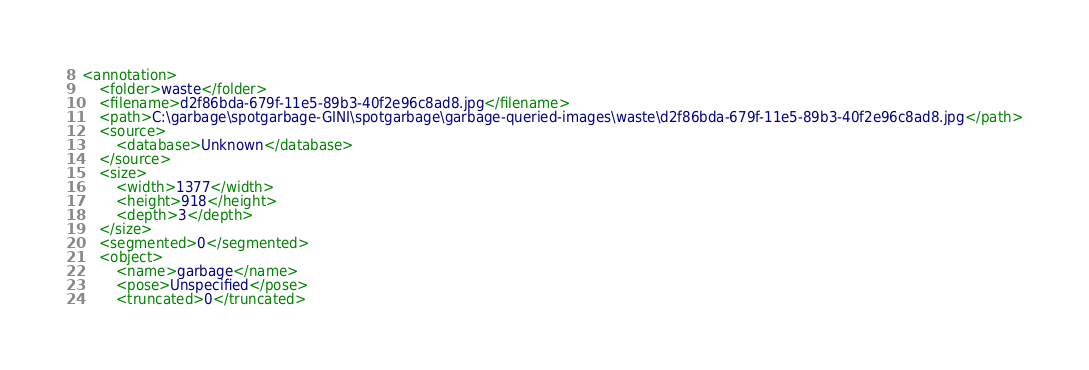<code> <loc_0><loc_0><loc_500><loc_500><_XML_><annotation>
	<folder>waste</folder>
	<filename>d2f86bda-679f-11e5-89b3-40f2e96c8ad8.jpg</filename>
	<path>C:\garbage\spotgarbage-GINI\spotgarbage\garbage-queried-images\waste\d2f86bda-679f-11e5-89b3-40f2e96c8ad8.jpg</path>
	<source>
		<database>Unknown</database>
	</source>
	<size>
		<width>1377</width>
		<height>918</height>
		<depth>3</depth>
	</size>
	<segmented>0</segmented>
	<object>
		<name>garbage</name>
		<pose>Unspecified</pose>
		<truncated>0</truncated></code> 